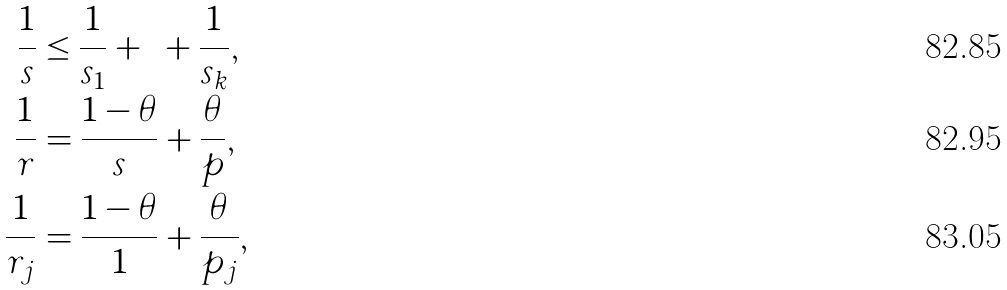<formula> <loc_0><loc_0><loc_500><loc_500>\text { } \frac { 1 } { s } & \leq \frac { 1 } { s _ { 1 } } + \cdots + \frac { 1 } { s _ { k } } , \\ \frac { 1 } { r } & = \frac { 1 - \theta } { s } + \frac { \theta } { p } , \\ \frac { 1 } { r _ { j } } & = \frac { 1 - \theta } { 1 } + \frac { \theta } { p _ { j } } ,</formula> 